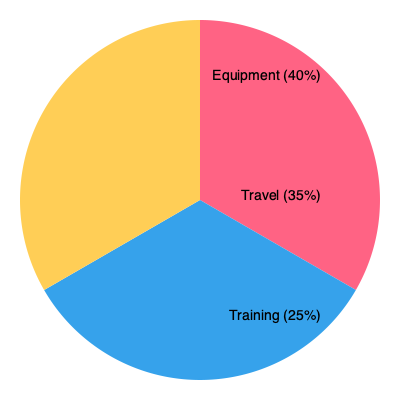A potential sponsor has offered you a deal worth $200,000. Based on the pie chart showing the typical breakdown of sponsorship allocation, how much would you expect to spend on equipment? To solve this problem, we need to follow these steps:

1. Identify the percentage allocated to equipment from the pie chart:
   The chart shows that 40% is allocated to equipment.

2. Calculate 40% of the total sponsorship amount:
   Total sponsorship = $200,000
   Percentage for equipment = 40% = 0.40

   Amount for equipment = Total sponsorship × Percentage for equipment
   Amount for equipment = $200,000 × 0.40
   Amount for equipment = $80,000

Therefore, based on the typical allocation shown in the pie chart, you would expect to spend $80,000 on equipment from the $200,000 sponsorship deal.
Answer: $80,000 